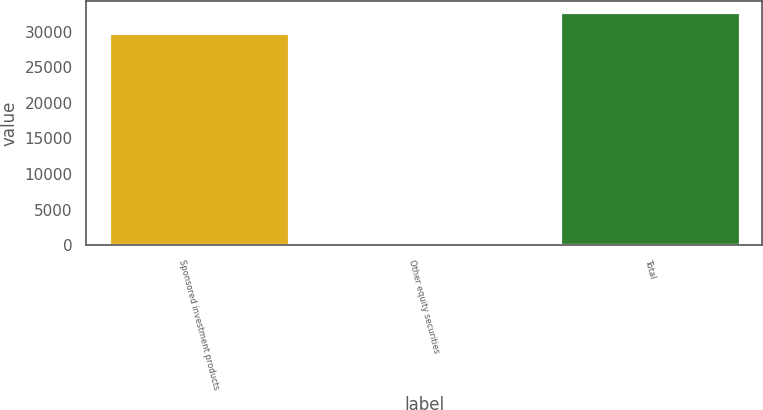Convert chart. <chart><loc_0><loc_0><loc_500><loc_500><bar_chart><fcel>Sponsored investment products<fcel>Other equity securities<fcel>Total<nl><fcel>29731<fcel>1<fcel>32707.1<nl></chart> 